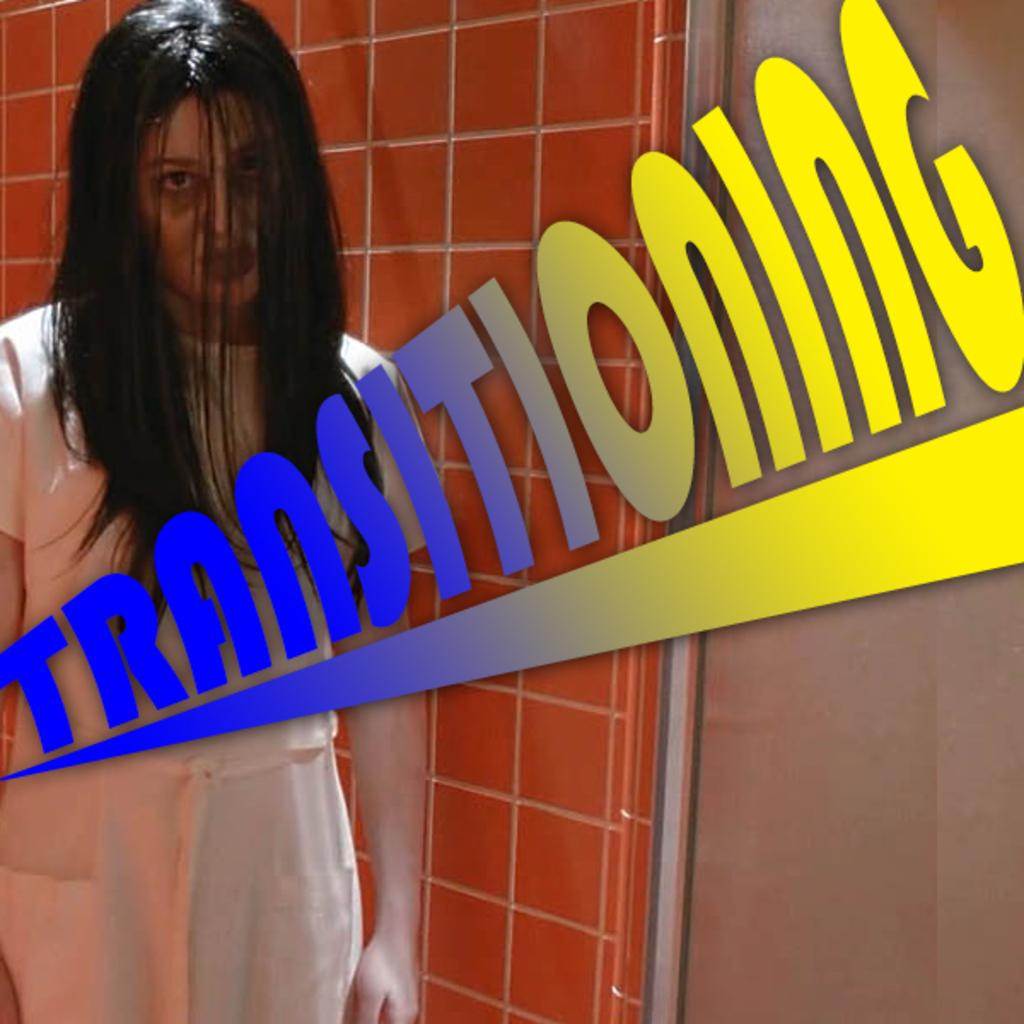Provide a one-sentence caption for the provided image. a picture of a zombie woman with the words TRANSITIONING in the front of it. 